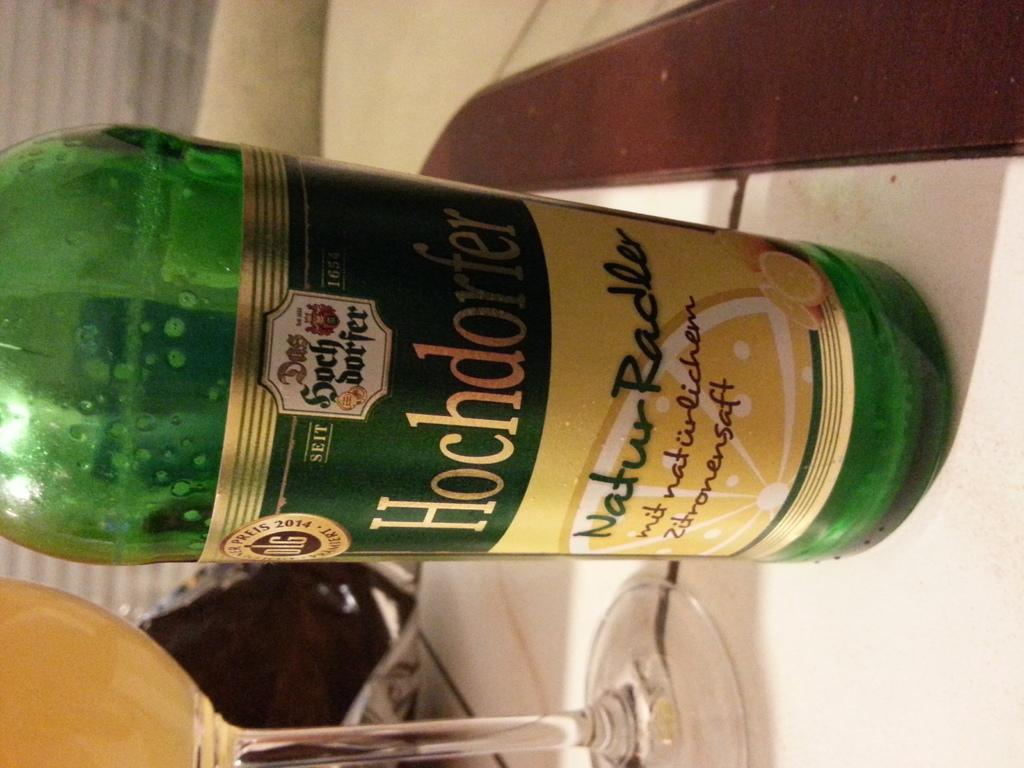What type of bottle is in the image? There is a green bottle in the image. What can be seen on the bottle? The bottle has a sticker with "HOCHDORFER" written on it. What is placed next to the bottle in the image? There is a glass of wine in the image. Where are the bottle and glass of wine located? The bottle and glass of wine are placed on a table. What type of guitar can be seen in the image? There is no guitar present in the image. Is the hospital visible in the background of the image? There is no hospital or any reference to a hospital in the image. 